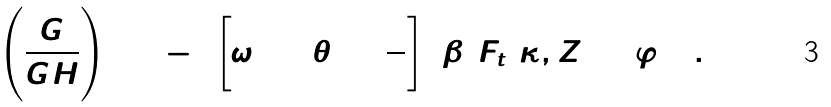Convert formula to latex. <formula><loc_0><loc_0><loc_500><loc_500>\left ( { \frac { \dot { G } } { G H } } \right ) _ { 0 } = - 2 \left [ \omega \tan \theta _ { 0 } + { \frac { 3 } { 4 } } \right ] ( \beta _ { 3 } F _ { t } ( \kappa , Z _ { 0 } ) \Delta \varphi ) ^ { 2 } \ .</formula> 